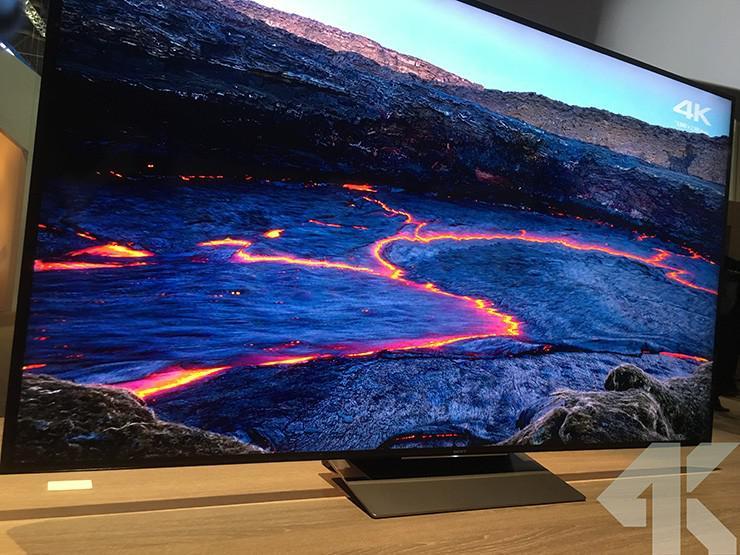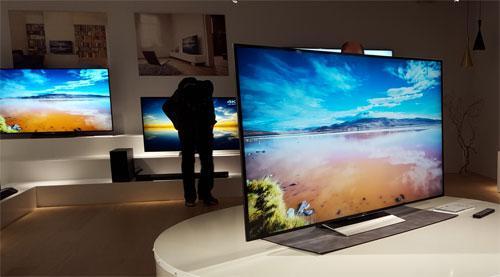The first image is the image on the left, the second image is the image on the right. For the images shown, is this caption "The right image contains more screened devices than the left image." true? Answer yes or no. Yes. The first image is the image on the left, the second image is the image on the right. Evaluate the accuracy of this statement regarding the images: "One of the televisions is in front of a bricked wall.". Is it true? Answer yes or no. No. 